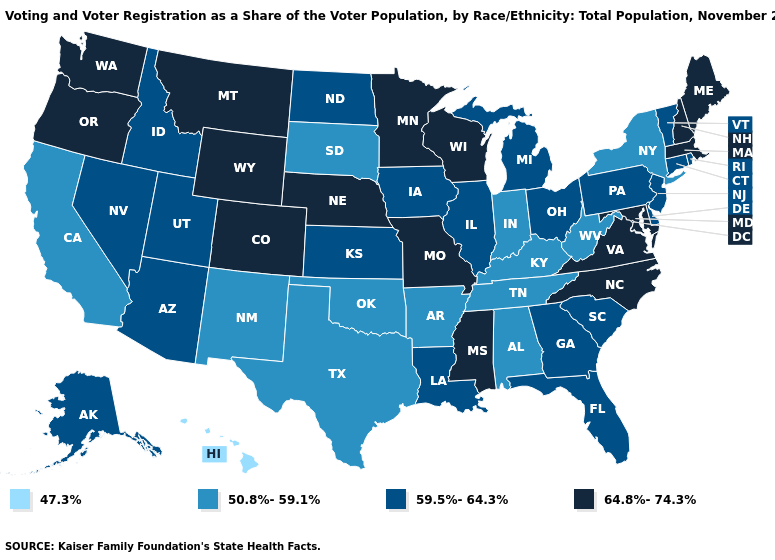Among the states that border Oklahoma , which have the highest value?
Write a very short answer. Colorado, Missouri. Does the map have missing data?
Keep it brief. No. What is the value of Michigan?
Give a very brief answer. 59.5%-64.3%. Among the states that border Nevada , which have the lowest value?
Concise answer only. California. What is the value of New Mexico?
Answer briefly. 50.8%-59.1%. What is the value of Oklahoma?
Concise answer only. 50.8%-59.1%. Name the states that have a value in the range 50.8%-59.1%?
Be succinct. Alabama, Arkansas, California, Indiana, Kentucky, New Mexico, New York, Oklahoma, South Dakota, Tennessee, Texas, West Virginia. Is the legend a continuous bar?
Quick response, please. No. What is the lowest value in the MidWest?
Short answer required. 50.8%-59.1%. What is the highest value in the South ?
Short answer required. 64.8%-74.3%. Which states have the lowest value in the MidWest?
Give a very brief answer. Indiana, South Dakota. Does Nevada have a lower value than Colorado?
Write a very short answer. Yes. Which states have the lowest value in the USA?
Be succinct. Hawaii. Among the states that border Michigan , which have the lowest value?
Answer briefly. Indiana. What is the value of Iowa?
Quick response, please. 59.5%-64.3%. 